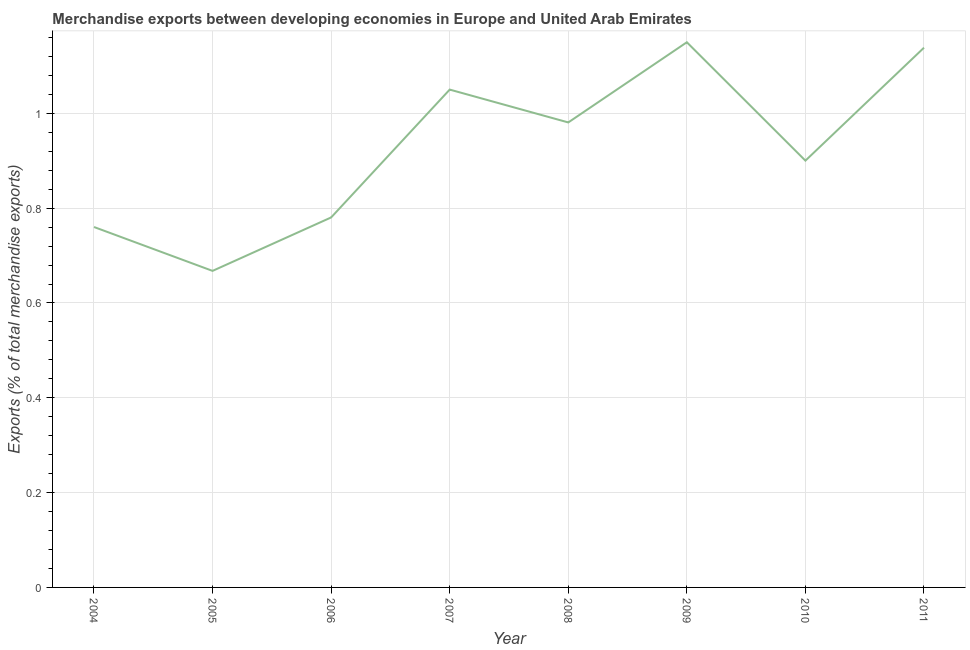What is the merchandise exports in 2006?
Your response must be concise. 0.78. Across all years, what is the maximum merchandise exports?
Offer a very short reply. 1.15. Across all years, what is the minimum merchandise exports?
Offer a very short reply. 0.67. In which year was the merchandise exports maximum?
Your response must be concise. 2009. What is the sum of the merchandise exports?
Your response must be concise. 7.43. What is the difference between the merchandise exports in 2004 and 2009?
Provide a short and direct response. -0.39. What is the average merchandise exports per year?
Ensure brevity in your answer.  0.93. What is the median merchandise exports?
Your answer should be very brief. 0.94. What is the ratio of the merchandise exports in 2006 to that in 2010?
Your answer should be compact. 0.87. What is the difference between the highest and the second highest merchandise exports?
Provide a short and direct response. 0.01. What is the difference between the highest and the lowest merchandise exports?
Make the answer very short. 0.48. Does the merchandise exports monotonically increase over the years?
Keep it short and to the point. No. How many lines are there?
Your answer should be compact. 1. How many years are there in the graph?
Your response must be concise. 8. What is the difference between two consecutive major ticks on the Y-axis?
Provide a succinct answer. 0.2. Does the graph contain any zero values?
Ensure brevity in your answer.  No. What is the title of the graph?
Provide a short and direct response. Merchandise exports between developing economies in Europe and United Arab Emirates. What is the label or title of the X-axis?
Make the answer very short. Year. What is the label or title of the Y-axis?
Your answer should be compact. Exports (% of total merchandise exports). What is the Exports (% of total merchandise exports) of 2004?
Make the answer very short. 0.76. What is the Exports (% of total merchandise exports) in 2005?
Your answer should be very brief. 0.67. What is the Exports (% of total merchandise exports) of 2006?
Provide a short and direct response. 0.78. What is the Exports (% of total merchandise exports) of 2007?
Keep it short and to the point. 1.05. What is the Exports (% of total merchandise exports) of 2008?
Provide a short and direct response. 0.98. What is the Exports (% of total merchandise exports) of 2009?
Your response must be concise. 1.15. What is the Exports (% of total merchandise exports) of 2010?
Keep it short and to the point. 0.9. What is the Exports (% of total merchandise exports) of 2011?
Give a very brief answer. 1.14. What is the difference between the Exports (% of total merchandise exports) in 2004 and 2005?
Your answer should be compact. 0.09. What is the difference between the Exports (% of total merchandise exports) in 2004 and 2006?
Make the answer very short. -0.02. What is the difference between the Exports (% of total merchandise exports) in 2004 and 2007?
Offer a terse response. -0.29. What is the difference between the Exports (% of total merchandise exports) in 2004 and 2008?
Ensure brevity in your answer.  -0.22. What is the difference between the Exports (% of total merchandise exports) in 2004 and 2009?
Keep it short and to the point. -0.39. What is the difference between the Exports (% of total merchandise exports) in 2004 and 2010?
Your answer should be very brief. -0.14. What is the difference between the Exports (% of total merchandise exports) in 2004 and 2011?
Your answer should be compact. -0.38. What is the difference between the Exports (% of total merchandise exports) in 2005 and 2006?
Make the answer very short. -0.11. What is the difference between the Exports (% of total merchandise exports) in 2005 and 2007?
Your response must be concise. -0.38. What is the difference between the Exports (% of total merchandise exports) in 2005 and 2008?
Your response must be concise. -0.31. What is the difference between the Exports (% of total merchandise exports) in 2005 and 2009?
Your answer should be very brief. -0.48. What is the difference between the Exports (% of total merchandise exports) in 2005 and 2010?
Provide a short and direct response. -0.23. What is the difference between the Exports (% of total merchandise exports) in 2005 and 2011?
Give a very brief answer. -0.47. What is the difference between the Exports (% of total merchandise exports) in 2006 and 2007?
Offer a very short reply. -0.27. What is the difference between the Exports (% of total merchandise exports) in 2006 and 2008?
Provide a short and direct response. -0.2. What is the difference between the Exports (% of total merchandise exports) in 2006 and 2009?
Provide a succinct answer. -0.37. What is the difference between the Exports (% of total merchandise exports) in 2006 and 2010?
Give a very brief answer. -0.12. What is the difference between the Exports (% of total merchandise exports) in 2006 and 2011?
Offer a terse response. -0.36. What is the difference between the Exports (% of total merchandise exports) in 2007 and 2008?
Give a very brief answer. 0.07. What is the difference between the Exports (% of total merchandise exports) in 2007 and 2009?
Give a very brief answer. -0.1. What is the difference between the Exports (% of total merchandise exports) in 2007 and 2010?
Your response must be concise. 0.15. What is the difference between the Exports (% of total merchandise exports) in 2007 and 2011?
Offer a very short reply. -0.09. What is the difference between the Exports (% of total merchandise exports) in 2008 and 2009?
Offer a terse response. -0.17. What is the difference between the Exports (% of total merchandise exports) in 2008 and 2010?
Keep it short and to the point. 0.08. What is the difference between the Exports (% of total merchandise exports) in 2008 and 2011?
Your answer should be very brief. -0.16. What is the difference between the Exports (% of total merchandise exports) in 2009 and 2010?
Make the answer very short. 0.25. What is the difference between the Exports (% of total merchandise exports) in 2009 and 2011?
Provide a succinct answer. 0.01. What is the difference between the Exports (% of total merchandise exports) in 2010 and 2011?
Offer a very short reply. -0.24. What is the ratio of the Exports (% of total merchandise exports) in 2004 to that in 2005?
Your answer should be very brief. 1.14. What is the ratio of the Exports (% of total merchandise exports) in 2004 to that in 2007?
Ensure brevity in your answer.  0.72. What is the ratio of the Exports (% of total merchandise exports) in 2004 to that in 2008?
Make the answer very short. 0.78. What is the ratio of the Exports (% of total merchandise exports) in 2004 to that in 2009?
Offer a very short reply. 0.66. What is the ratio of the Exports (% of total merchandise exports) in 2004 to that in 2010?
Offer a very short reply. 0.84. What is the ratio of the Exports (% of total merchandise exports) in 2004 to that in 2011?
Ensure brevity in your answer.  0.67. What is the ratio of the Exports (% of total merchandise exports) in 2005 to that in 2006?
Your answer should be compact. 0.86. What is the ratio of the Exports (% of total merchandise exports) in 2005 to that in 2007?
Provide a short and direct response. 0.64. What is the ratio of the Exports (% of total merchandise exports) in 2005 to that in 2008?
Make the answer very short. 0.68. What is the ratio of the Exports (% of total merchandise exports) in 2005 to that in 2009?
Provide a succinct answer. 0.58. What is the ratio of the Exports (% of total merchandise exports) in 2005 to that in 2010?
Give a very brief answer. 0.74. What is the ratio of the Exports (% of total merchandise exports) in 2005 to that in 2011?
Give a very brief answer. 0.59. What is the ratio of the Exports (% of total merchandise exports) in 2006 to that in 2007?
Keep it short and to the point. 0.74. What is the ratio of the Exports (% of total merchandise exports) in 2006 to that in 2008?
Ensure brevity in your answer.  0.8. What is the ratio of the Exports (% of total merchandise exports) in 2006 to that in 2009?
Your answer should be very brief. 0.68. What is the ratio of the Exports (% of total merchandise exports) in 2006 to that in 2010?
Provide a short and direct response. 0.87. What is the ratio of the Exports (% of total merchandise exports) in 2006 to that in 2011?
Keep it short and to the point. 0.69. What is the ratio of the Exports (% of total merchandise exports) in 2007 to that in 2008?
Your response must be concise. 1.07. What is the ratio of the Exports (% of total merchandise exports) in 2007 to that in 2009?
Ensure brevity in your answer.  0.91. What is the ratio of the Exports (% of total merchandise exports) in 2007 to that in 2010?
Offer a terse response. 1.17. What is the ratio of the Exports (% of total merchandise exports) in 2007 to that in 2011?
Give a very brief answer. 0.92. What is the ratio of the Exports (% of total merchandise exports) in 2008 to that in 2009?
Offer a very short reply. 0.85. What is the ratio of the Exports (% of total merchandise exports) in 2008 to that in 2010?
Make the answer very short. 1.09. What is the ratio of the Exports (% of total merchandise exports) in 2008 to that in 2011?
Your response must be concise. 0.86. What is the ratio of the Exports (% of total merchandise exports) in 2009 to that in 2010?
Keep it short and to the point. 1.28. What is the ratio of the Exports (% of total merchandise exports) in 2009 to that in 2011?
Your response must be concise. 1.01. What is the ratio of the Exports (% of total merchandise exports) in 2010 to that in 2011?
Provide a short and direct response. 0.79. 